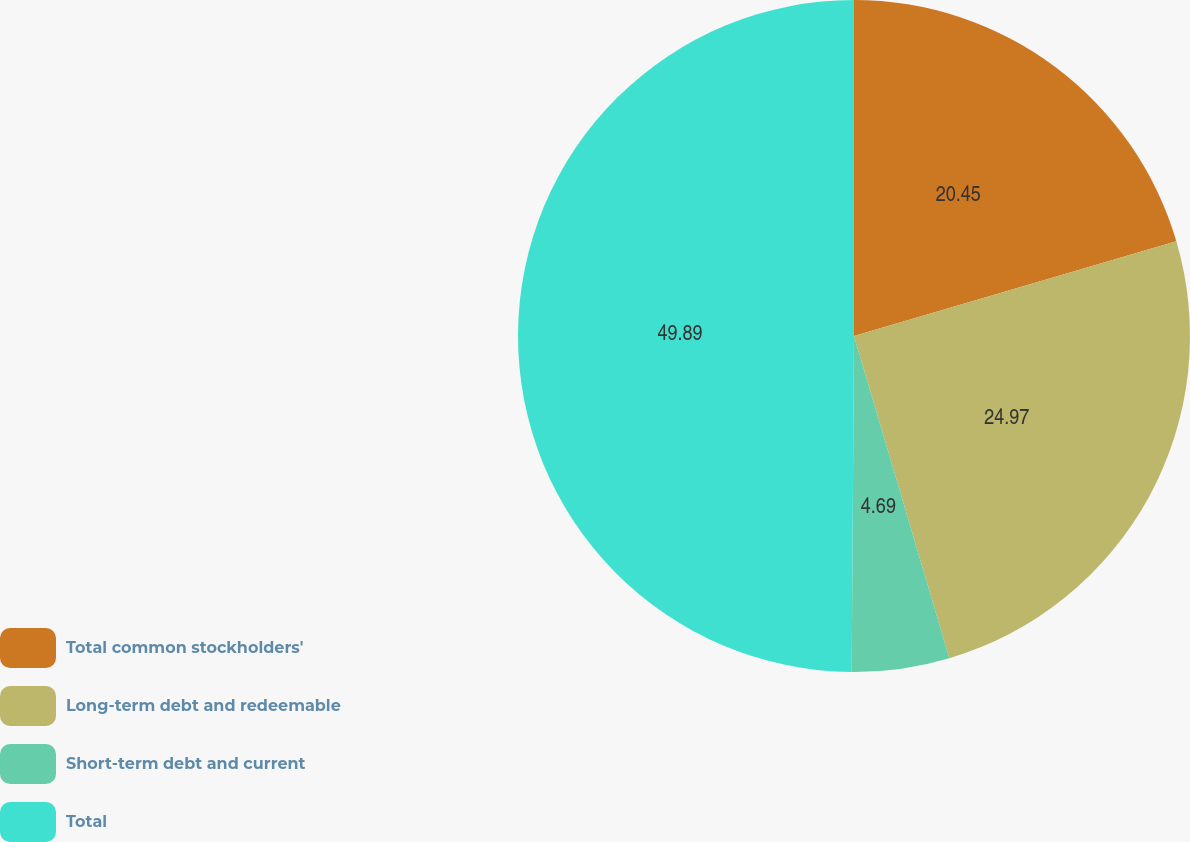<chart> <loc_0><loc_0><loc_500><loc_500><pie_chart><fcel>Total common stockholders'<fcel>Long-term debt and redeemable<fcel>Short-term debt and current<fcel>Total<nl><fcel>20.45%<fcel>24.97%<fcel>4.69%<fcel>49.89%<nl></chart> 